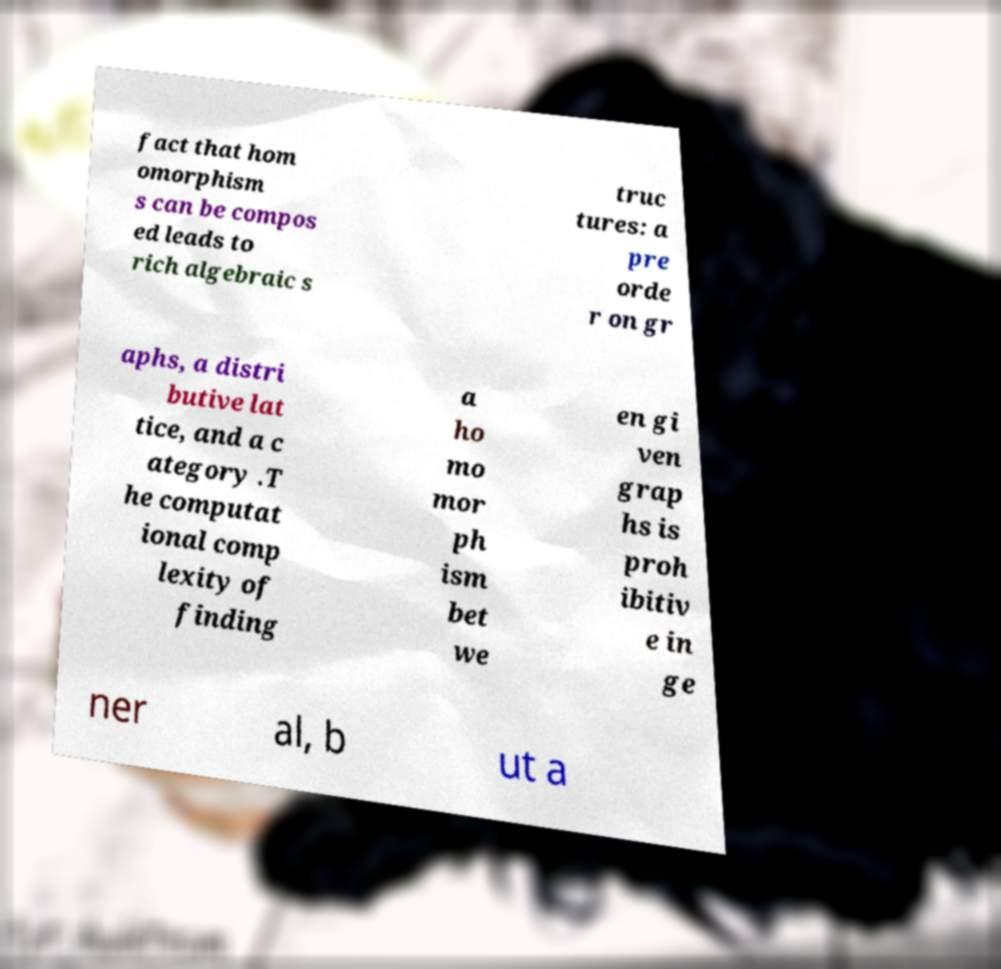For documentation purposes, I need the text within this image transcribed. Could you provide that? fact that hom omorphism s can be compos ed leads to rich algebraic s truc tures: a pre orde r on gr aphs, a distri butive lat tice, and a c ategory .T he computat ional comp lexity of finding a ho mo mor ph ism bet we en gi ven grap hs is proh ibitiv e in ge ner al, b ut a 